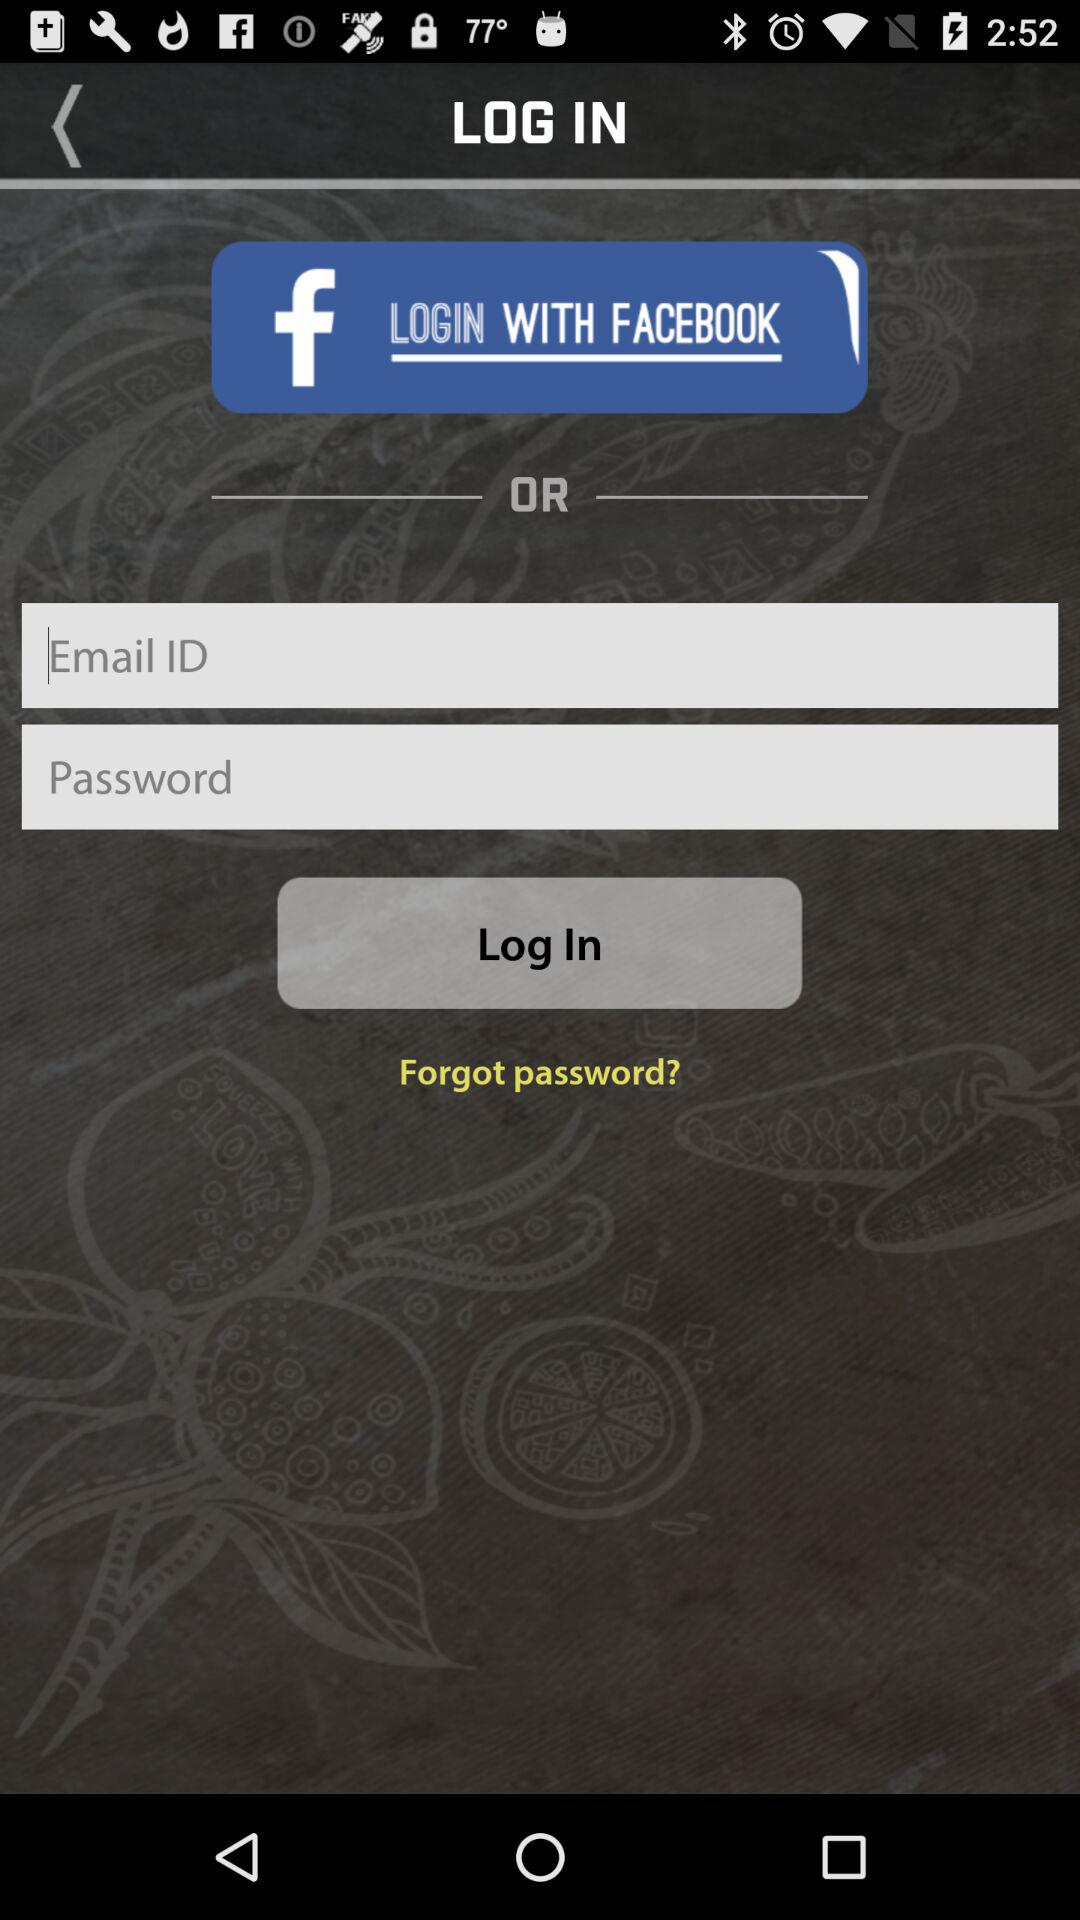What application can a user use to log in? A user can use to log in with "FACEBOOK". 